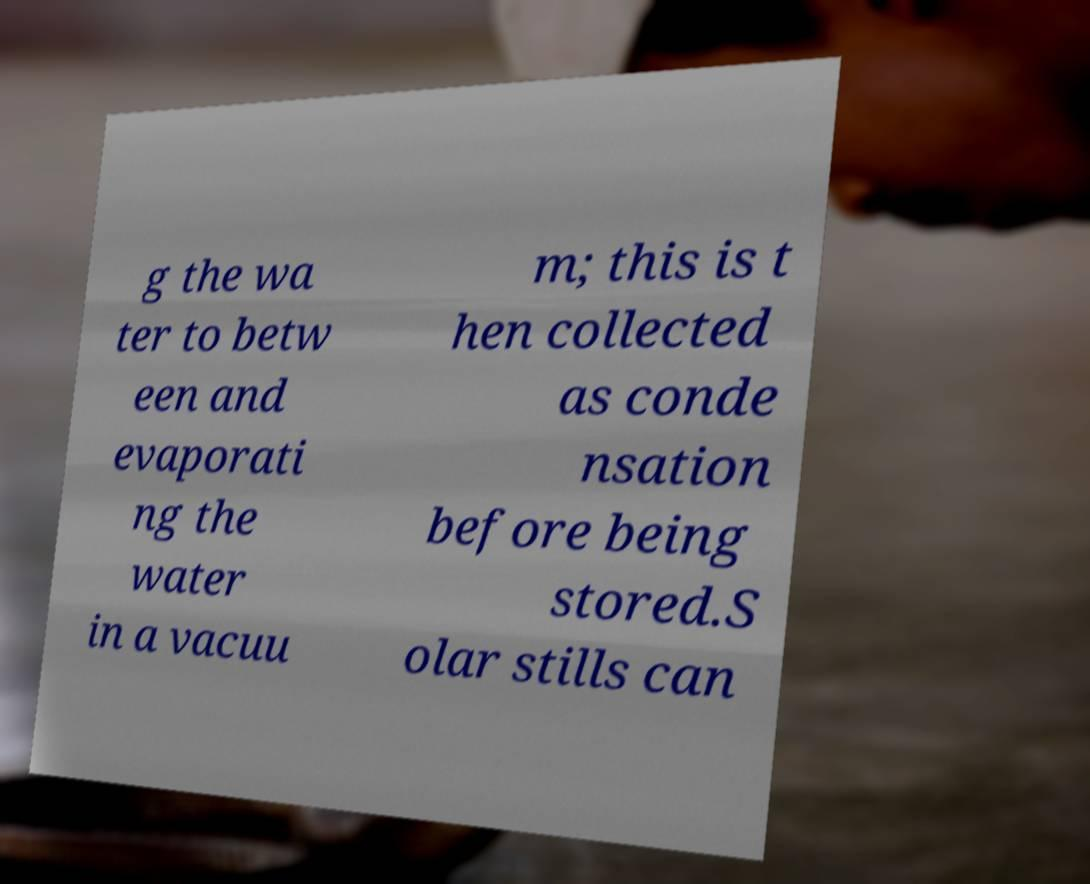What messages or text are displayed in this image? I need them in a readable, typed format. g the wa ter to betw een and evaporati ng the water in a vacuu m; this is t hen collected as conde nsation before being stored.S olar stills can 